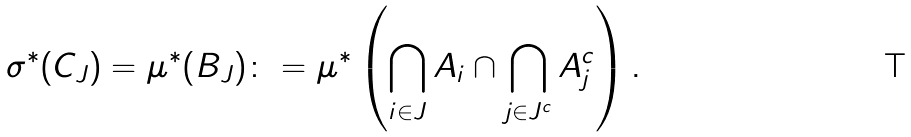Convert formula to latex. <formula><loc_0><loc_0><loc_500><loc_500>\sigma ^ { * } ( C _ { J } ) = \mu ^ { * } ( B _ { J } ) \colon = \mu ^ { * } \left ( \bigcap _ { i \in J } A _ { i } \cap \bigcap _ { j \in J ^ { c } } A _ { j } ^ { c } \right ) .</formula> 